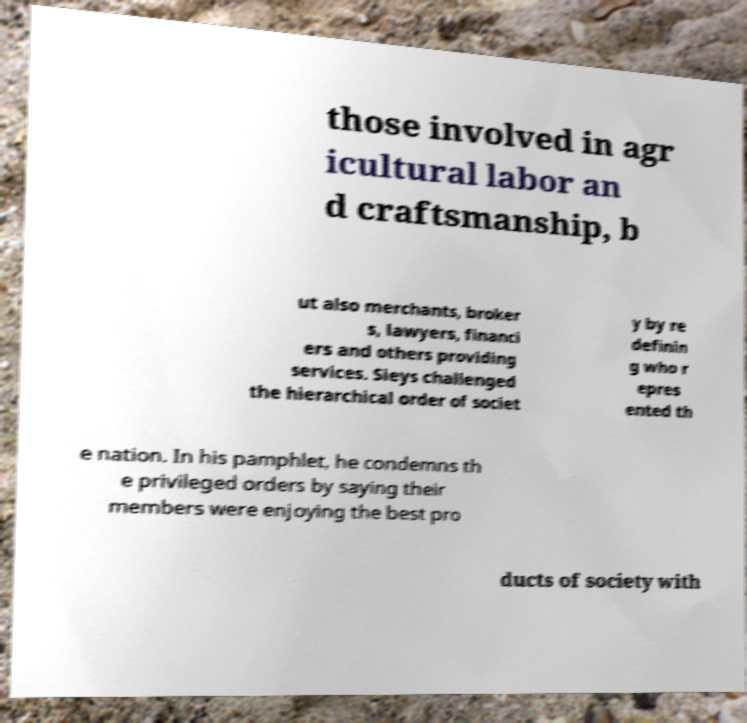What messages or text are displayed in this image? I need them in a readable, typed format. those involved in agr icultural labor an d craftsmanship, b ut also merchants, broker s, lawyers, financi ers and others providing services. Sieys challenged the hierarchical order of societ y by re definin g who r epres ented th e nation. In his pamphlet, he condemns th e privileged orders by saying their members were enjoying the best pro ducts of society with 